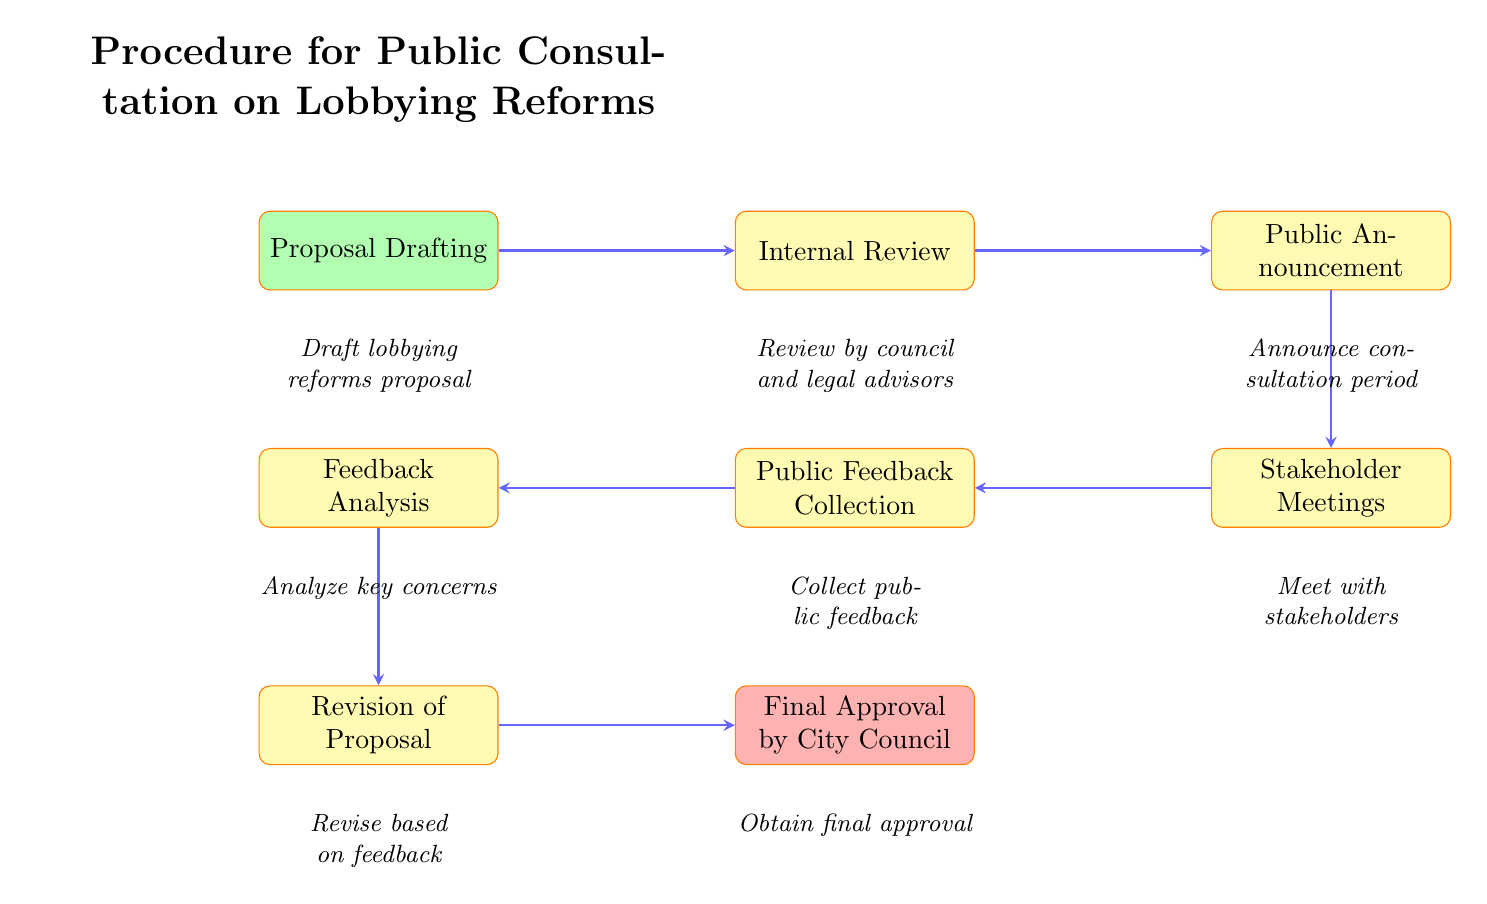what is the first step in the procedure? The diagram indicates that the first step in the procedure is “Proposal Drafting.” This is the starting point of the flowchart and serves as the first node.
Answer: Proposal Drafting how many processes are involved in the procedure? By counting each process node in the diagram, there are six process steps: Internal Review, Public Announcement, Stakeholder Meetings, Public Feedback Collection, Feedback Analysis, and Revision of Proposal.
Answer: six what is the last step in the procedure? The last step depicted in the flowchart is “Final Approval by City Council.” This indicates the conclusion of the process.
Answer: Final Approval by City Council which node comes after Public Announcement? The flowchart shows that after the Public Announcement node, the next step is Stakeholder Meetings. This can be traced directly in the flow of the diagram.
Answer: Stakeholder Meetings what is the relationship between Feedback Collection and Feedback Analysis? The arrows connecting these two nodes indicate that Feedback Collection leads directly to Feedback Analysis, illustrating the flow of the procedure from public input to the analysis stage.
Answer: Feedback Collection leads to Feedback Analysis what step follows Revision of Proposal? According to the sequence in the diagram, the step that follows Revision of Proposal is Final Approval by City Council. This is indicated by the direct connection between these two nodes.
Answer: Final Approval by City Council during which step is public feedback collected? Public feedback is collected during the “Public Feedback Collection” step, as indicated in that specific node within the flowchart.
Answer: Public Feedback Collection how many connections are there in the flowchart? The diagram shows a total of seven connections (arrows) linking the various nodes, illustrating the sequence of steps in the consultation procedure.
Answer: seven what occurs between Stakeholder Meetings and Public Feedback Collection? The diagram indicates that the flow goes directly from Stakeholder Meetings to Public Feedback Collection without any intermediate steps, showing a direct transition between these two processes.
Answer: direct transition 